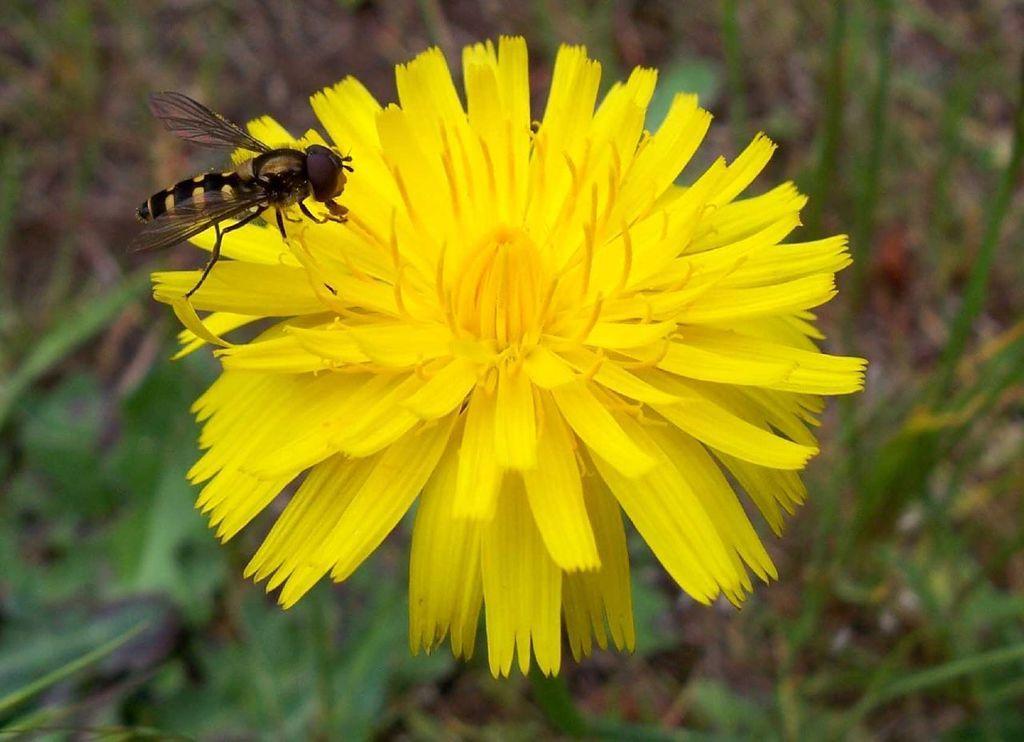Can you describe this image briefly? In this image we can see a flower which is in yellow color and a bee on it. 